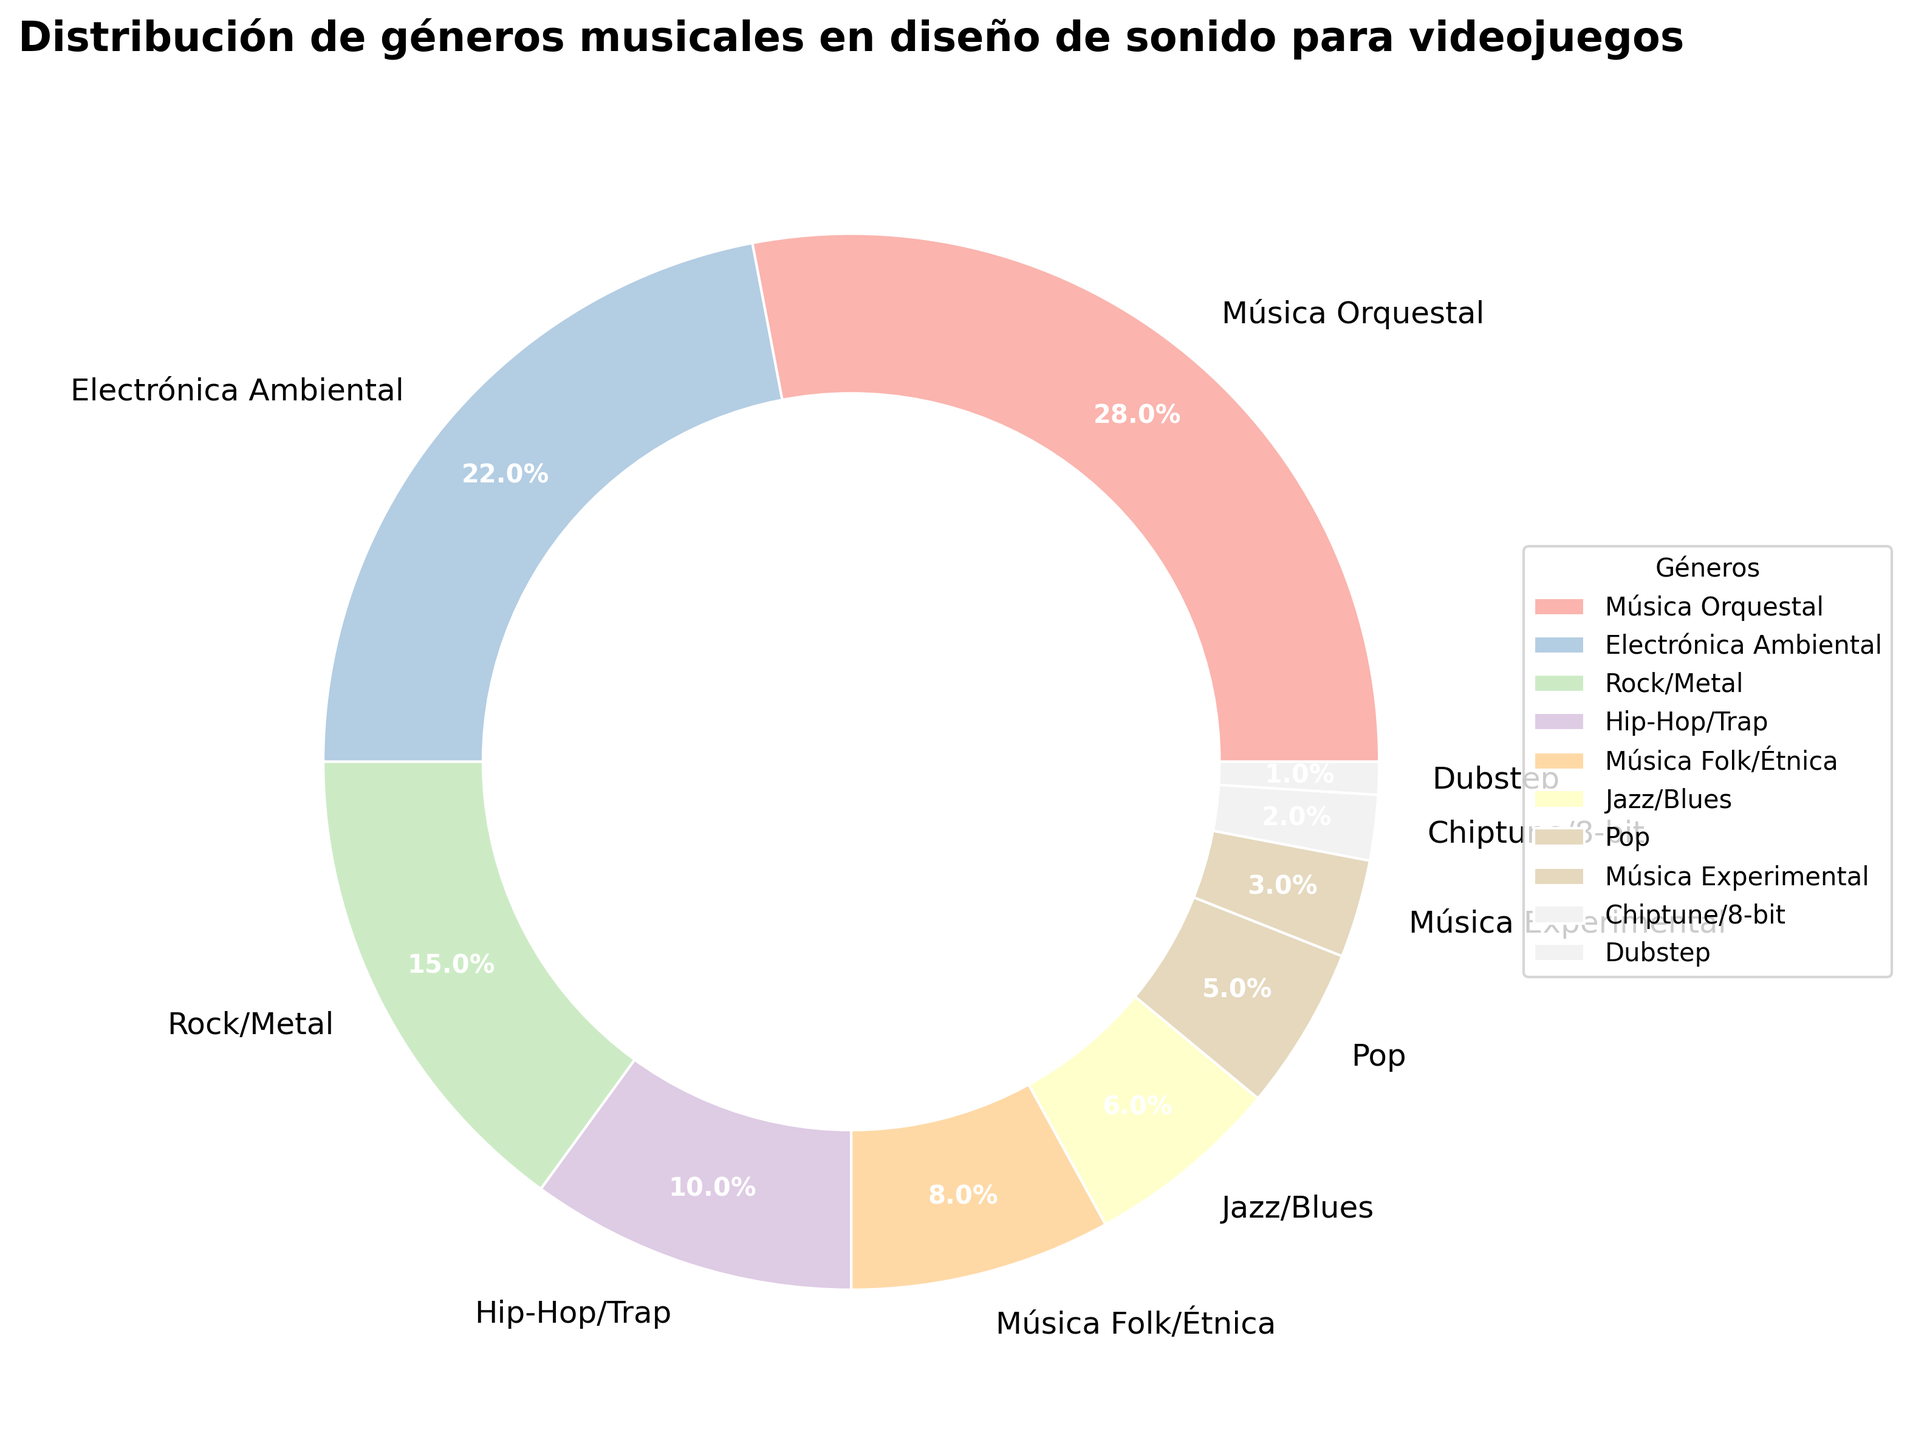¿Cuál es el género musical más utilizado en el diseño de sonido para videojuegos? Al observar el gráfico, se puede ver que el segmento más grande del pastel corresponde a Música Orquestal con un 28%.
Answer: Música Orquestal ¿Qué géneros tienen una proporción igual o menor al 5% en el diseño de sonido para videojuegos? En el gráfico, los géneros que tienen segmentos pequeños con porcentajes al lado son Pop (5%), Música Experimental (3%), Chiptune/8-bit (2%) y Dubstep (1%).
Answer: Pop, Música Experimental, Chiptune/8-bit, Dubstep ¿Cuál es la diferencia en porcentaje entre Música Orquestal y Electrónica Ambiental? Debemos restar el porcentaje de Electrónica Ambiental (22%) al de Música Orquestal (28%), lo que resulta en 28% - 22% = 6%.
Answer: 6% ¿Cuál es el porcentaje total de géneros que recaen en las categorías de Hip-Hop/Trap, Música Folk/Étnica, y Jazz/Blues juntos? Sumamos los porcentajes de Hip-Hop/Trap (10%), Música Folk/Étnica (8%) y Jazz/Blues (6%). La suma es 10% + 8% + 6% = 24%.
Answer: 24% ¿Qué género tiene la proporción más baja y cuál es su porcentaje? El gráfico muestra que Dubstep tiene el segmento más pequeño, con un porcentaje del 1%.
Answer: Dubstep, 1% ¿Cuántos géneros tienen una proporción mayor al 20% en el diseño de sonido para videojuegos? Observando el gráfico, notamos que solo dos géneros tienen porcentajes superiores al 20%, que son Música Orquestal (28%) y Electrónica Ambiental (22%).
Answer: 2 géneros ¿Cuál es el segundo género musical más utilizado en el diseño de sonido para videojuegos? El segundo segmento más grande en el gráfico pertenece a Electrónica Ambiental con un 22%.
Answer: Electrónica Ambiental Dado su porcentaje, ¿se podría decir que Chiptune/8-bit y Dubstep combinados tienen una mayor proporción que Música Folk/Étnica? Sumamos los porcentajes de Chiptune/8-bit (2%) y Dubstep (1%) y comparamos el resultado con el de Música Folk/Étnica (8%). La suma es 2% + 1% = 3%, que es menor que 8%.
Answer: No ¿Qué colores se utilizan para representar Jazz/Blues y Pop en el gráfico? En el gráfico, los géneros están coloreados usando una paleta personalizada; Jazz/Blues y Pop están representados por dos colores diferentes de tonos pastel.
Answer: Tonos pastel (sin mencionar los colores exactos debido a la variabilidad de la paleta) 